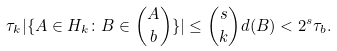<formula> <loc_0><loc_0><loc_500><loc_500>\tau _ { k } | \{ A \in H _ { k } \colon B \in \binom { A } { b } \} | \leq \binom { s } { k } d ( B ) < 2 ^ { s } \tau _ { b } .</formula> 